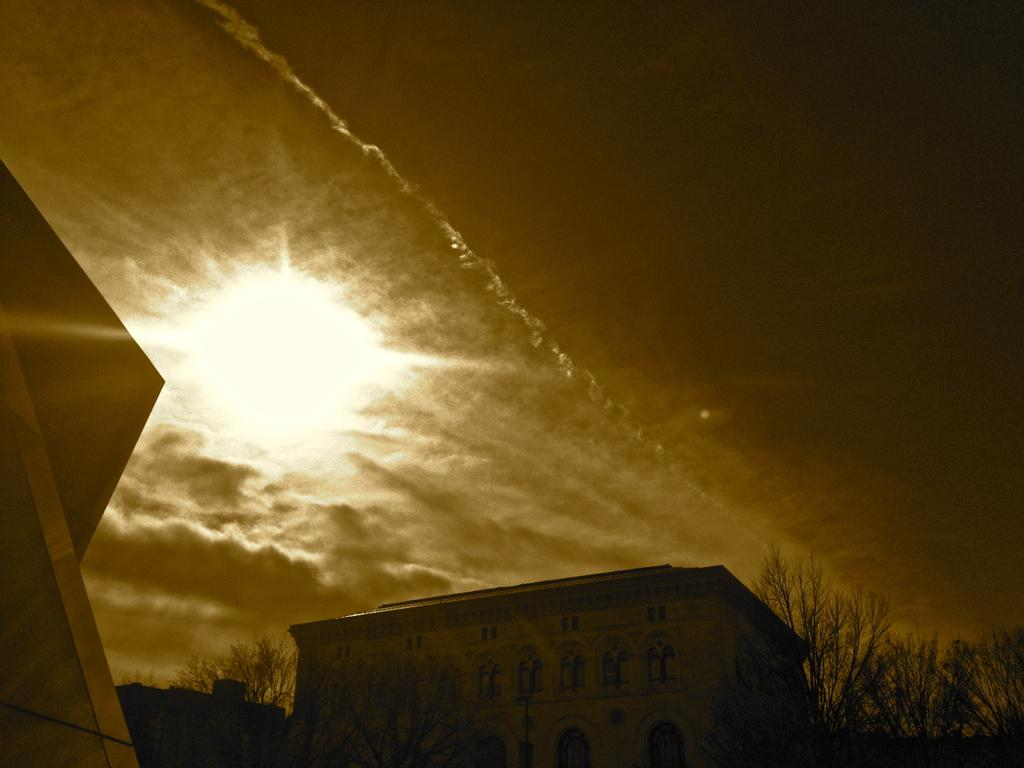What type of natural elements can be seen in the image? There are many trees in the image. What type of man-made structures are present in the image? There are buildings in the image. What can be seen in the background of the image? There are clouds, the sun, and the sky visible in the background of the image. How many sisters are sitting under the tent in the image? There is no tent or sisters present in the image. What type of cat can be seen playing with the trees in the image? There is no cat present in the image, and the trees are not depicted as playing with any animals. 